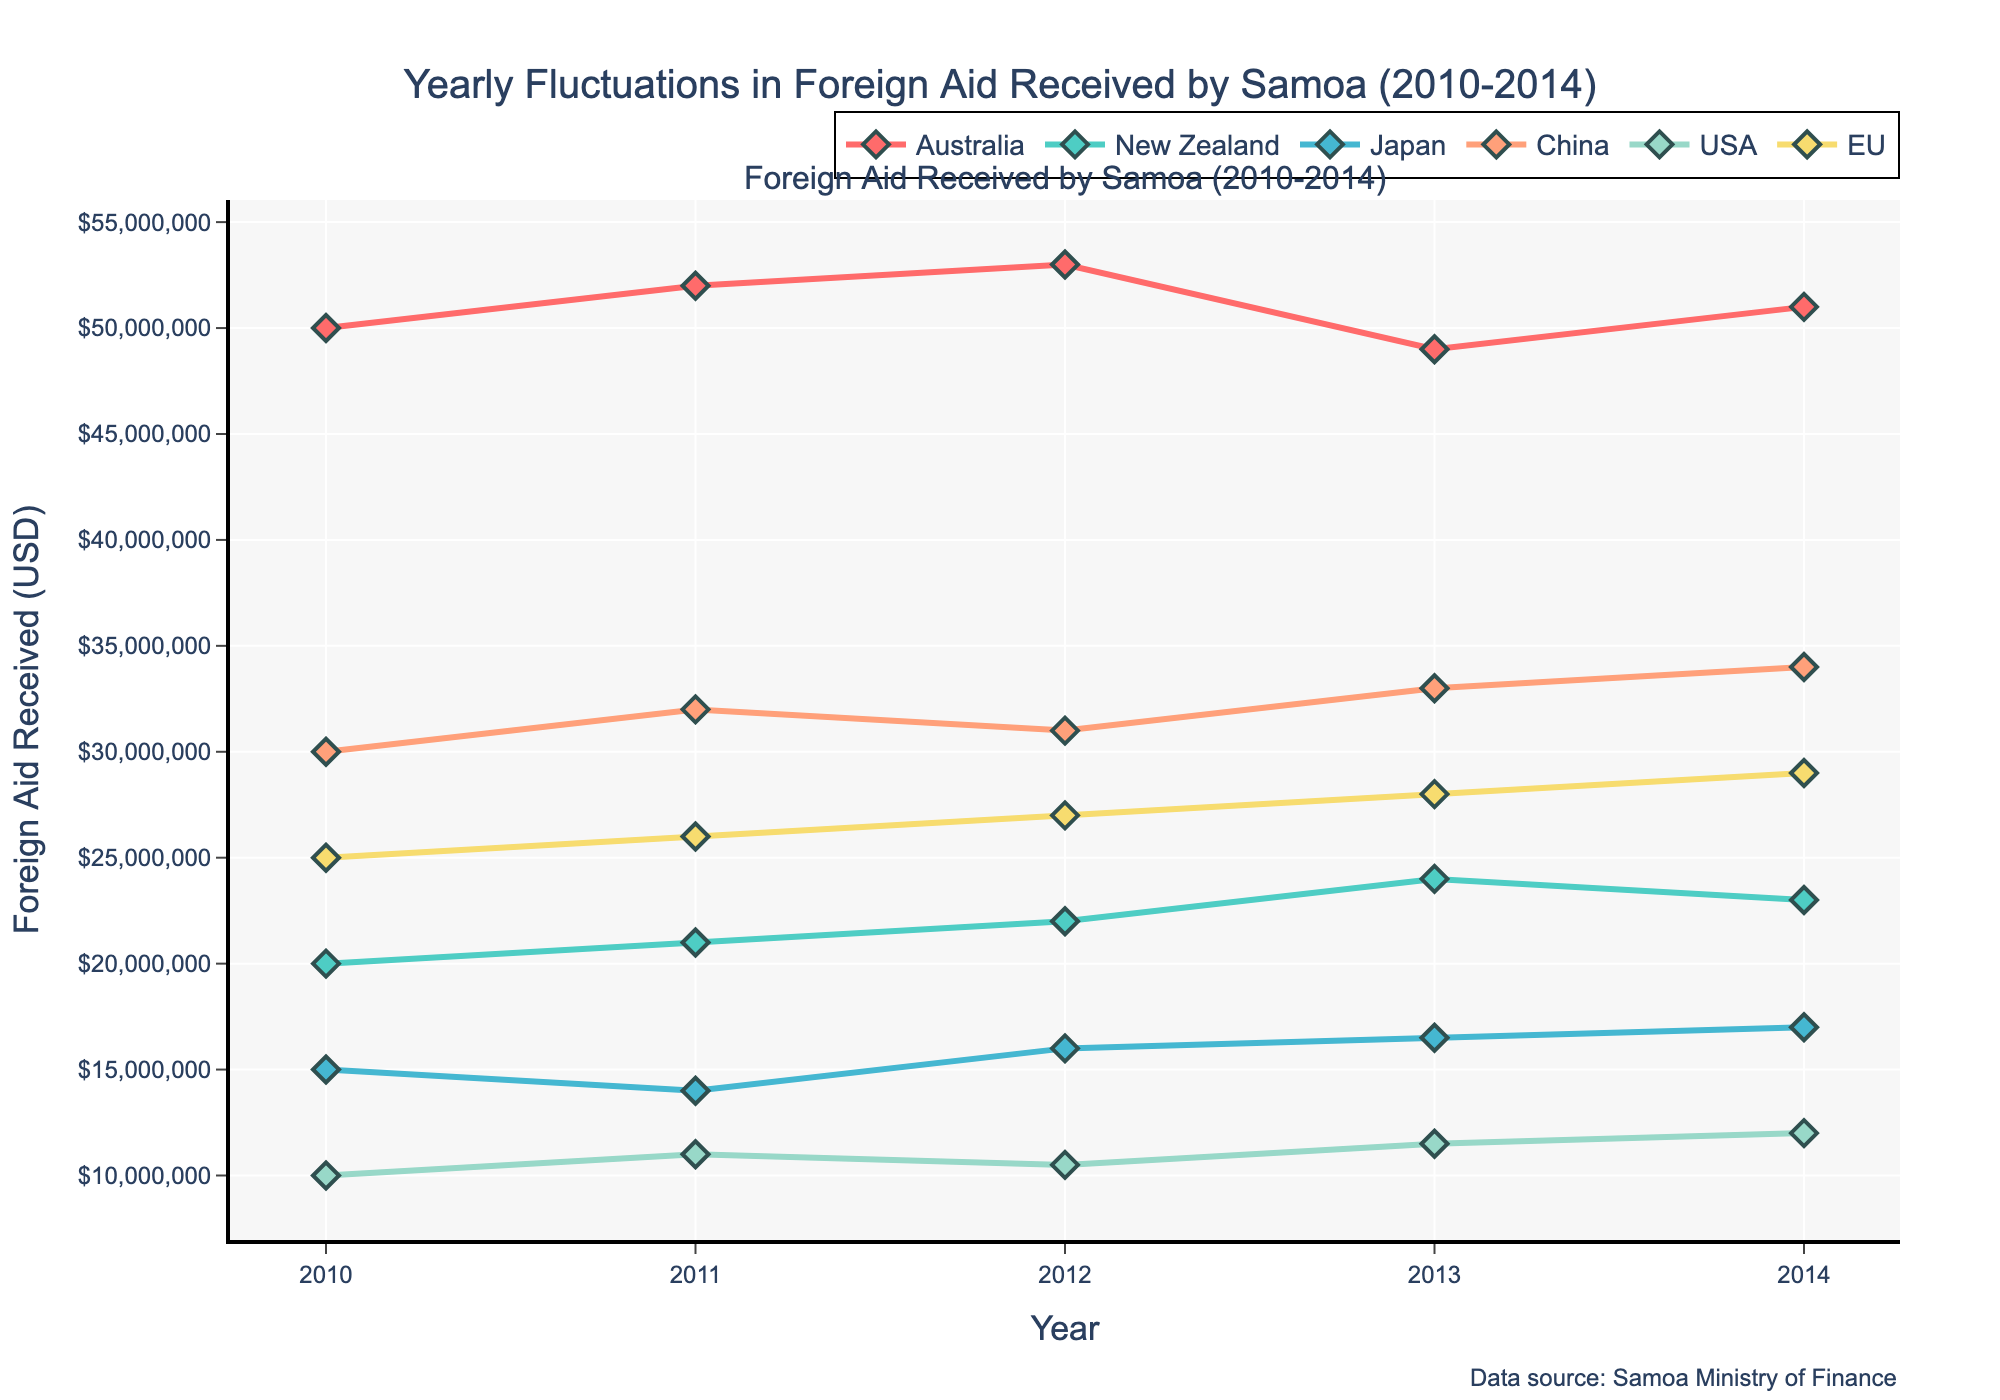Which donor country provided the highest amount of foreign aid in 2014? By locating the year 2014 on the x-axis and comparing the y-values (Foreign Aid Received) for each donor country, we can see that Australia provided the highest amount of aid in 2014.
Answer: Australia What is the overall trend of foreign aid received from Japan between 2010 and 2014? Observing the line representing Japan from 2010 to 2014, we see a general upward trend starting from $15 million in 2010 to $17 million in 2014.
Answer: Upward trend Which donor country's foreign aid showed the most fluctuation from 2010 to 2014? By comparing the amplitude changes in the y-axis across the lines for each country, Australia shows the largest fluctuation, with aid amounts ranging between $49 million and $53 million.
Answer: Australia How does the foreign aid received from the USA in 2014 compare to that from New Zealand in 2014? Referring to the y-axis values for the USA and New Zealand in 2014, the USA provided $12 million while New Zealand provided $23 million.
Answer: USA aid is lower What was the percentage increase in foreign aid received from China from 2010 to 2014? Calculate the percentage increase: [(Aid received in 2014 - Aid received in 2010) / Aid received in 2010] * 100. This is [(34,000,000 - 30,000,000) / 30,000,000] * 100 = (4,000,000 / 30,000,000) * 100 ≈ 13.33%.
Answer: 13.33% Which donor country provided the least amount of foreign aid to Samoa consistently over the years 2010-2014? By comparing the y-values across all years 2010-2014, the USA consistently provided the least amount of foreign aid, varying between $10 million and $12 million.
Answer: USA What is the average foreign aid received from the EU between 2010 and 2014? Sum the foreign aid amounts from the EU over the years 2010-2014 and divide by the number of years: (25,000,000 + 26,000,000 + 27,000,000 + 28,000,000 + 29,000,000) / 5 = 135,000,000 / 5 = 27,000,000.
Answer: $27 million How did the foreign aid from Australia in 2013 compare to 2012? Referring to the y-values for Australia in the years 2012 and 2013, aid decreased from $53 million in 2012 to $49 million in 2013.
Answer: Decreased Identify the year when New Zealand's foreign aid received the largest increase. By comparing the y-values between consecutive years for New Zealand, the largest increase was from 2012 to 2013, where aid increased from $22 million to $24 million.
Answer: 2013 